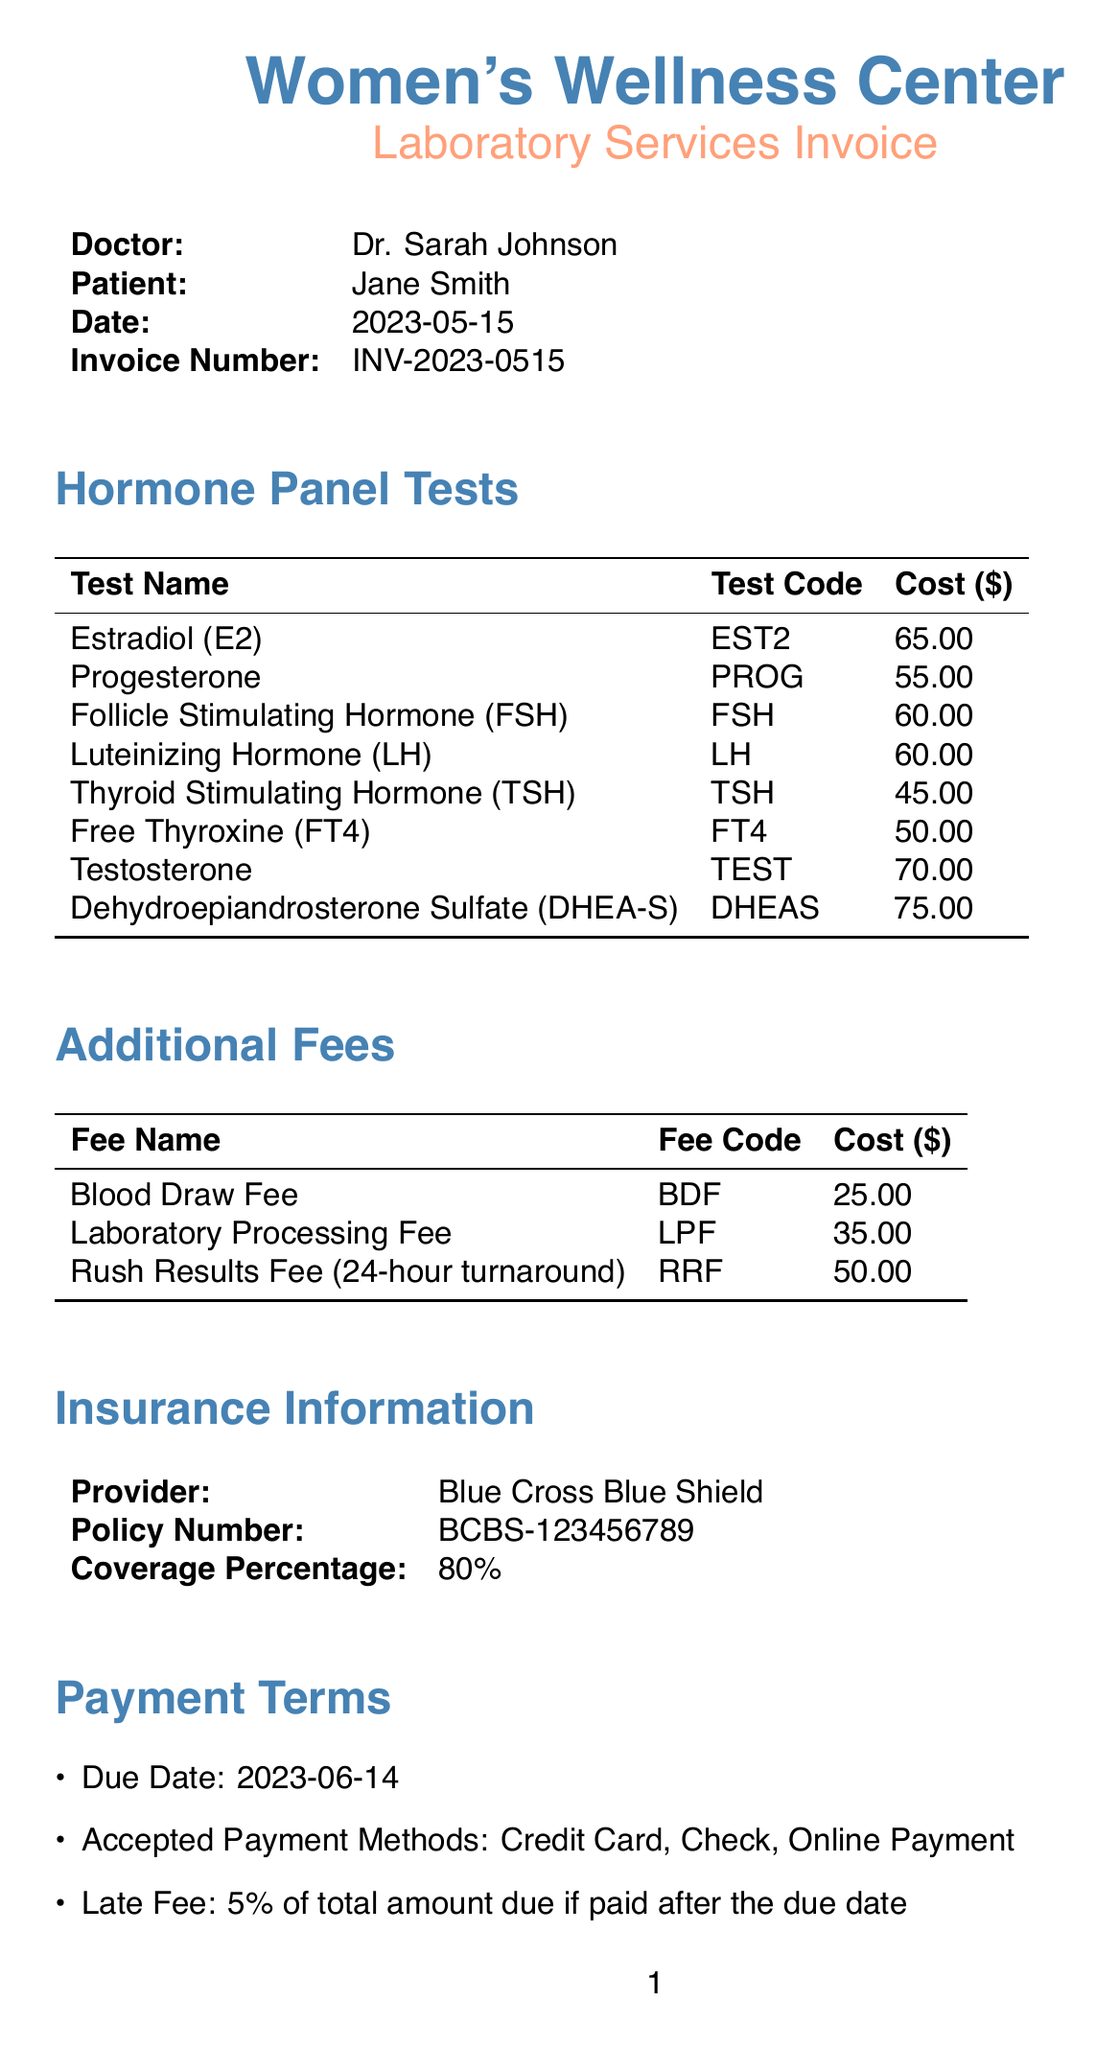what is the name of the clinic? The clinic name is listed in the document under the header section, which states "Women's Wellness Center."
Answer: Women's Wellness Center who is the doctor? The doctor's name is provided in the document, stating "Dr. Sarah Johnson."
Answer: Dr. Sarah Johnson what is the date of the invoice? The date is mentioned prominently in the document as "2023-05-15."
Answer: 2023-05-15 how much does the Blood Draw Fee cost? The cost for the Blood Draw Fee is specifically mentioned in the additional fees section of the document as "$25.00."
Answer: $25.00 what is the total cost of all hormone panel tests? The total cost can be calculated by summing all individual test costs listed under hormone panel tests. The total is $65 + $55 + $60 + $60 + $45 + $50 + $70 + $75 = $ 490.
Answer: $490 how much of the bill is covered by insurance? The insurance coverage percentage is indicated as 80%, meaning that 80% of the total billed amount will be covered.
Answer: 80% what are the accepted payment methods? The document lists accepted payment methods under payment terms, which include "Credit Card, Check, Online Payment."
Answer: Credit Card, Check, Online Payment when is the due date for payment? The due date for the invoice is stated in the payment terms section as "2023-06-14."
Answer: 2023-06-14 what additional notes are provided regarding the blood draw? The document provides specific notes about fasting, stating "Please fast for 8-12 hours before blood draw for accurate results."
Answer: Please fast for 8-12 hours before blood draw for accurate results 